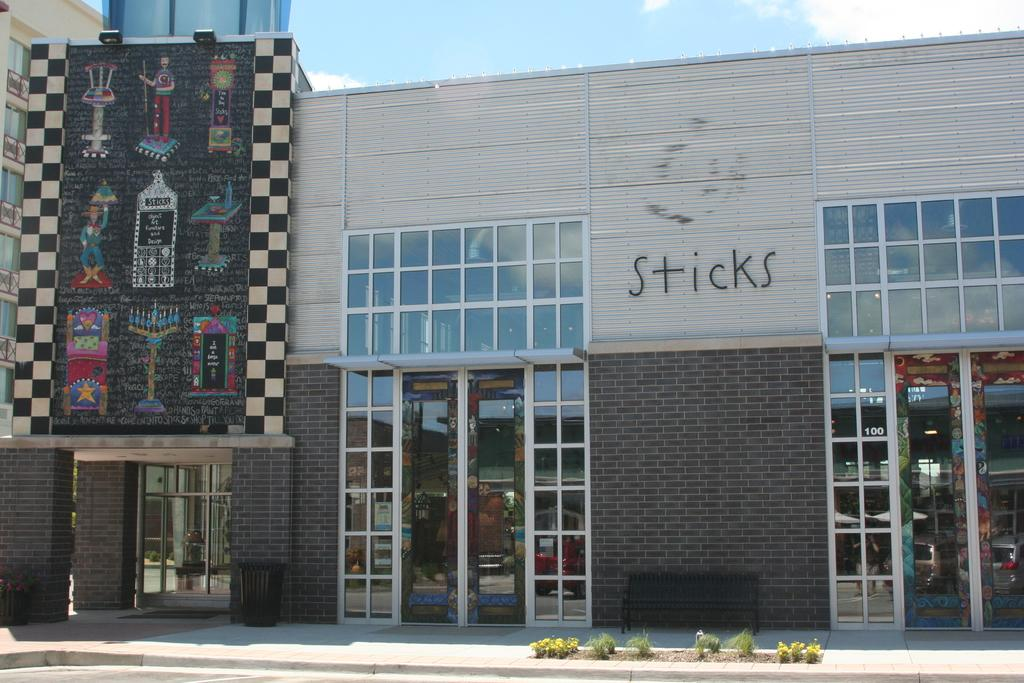<image>
Relay a brief, clear account of the picture shown. the brick outside exterior of Sticks design shop 